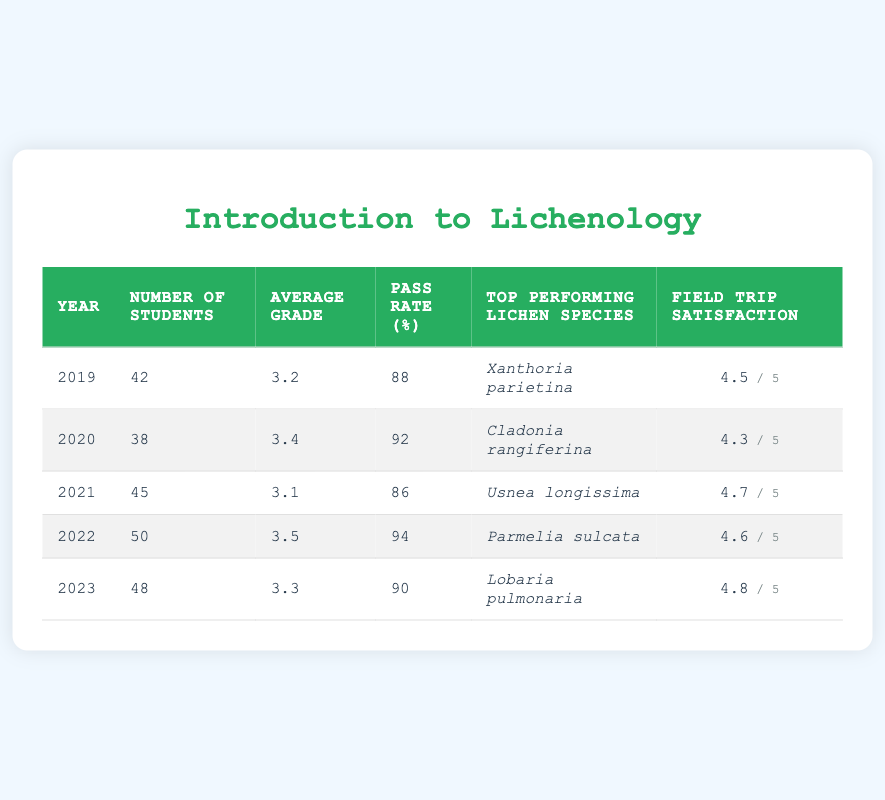What was the average grade of students in 2020? The average grade for the year 2020 is directly listed in the table under the "Average Grade" column. It shows a value of 3.4 for that year.
Answer: 3.4 How many students passed the course in 2021? The pass rate for 2021 is 86%. To find the number of students who passed, we calculate 86% of the 45 students, which is 0.86 * 45 = 38.7, rounding down gives us 38 students.
Answer: 38 What was the highest field trip satisfaction score recorded in the table? The field trip satisfaction scores are listed under the "Field Trip Satisfaction" column. Scanning through these values, the highest is 4.8 which corresponds to the year 2023.
Answer: 4.8 Did the number of students increase from 2019 to 2022? The number of students in 2019 was 42, and in 2022 it was 50. Since 50 is greater than 42, this confirms an increase from 2019 to 2022.
Answer: Yes What is the average pass rate over the five years? To find the average pass rate, we sum the pass rates from each year: (88 + 92 + 86 + 94 + 90) = 450. Then, we divide by the number of years, which is 5. So, the average pass rate is 450/5 = 90.
Answer: 90 Which year had the lowest average grade? By looking through the "Average Grade" column, we see that 3.1 in 2021 is the lowest value compared to other years.
Answer: 2021 What was the most commonly reported top-performing lichen species in the past five years? We look at the "Top Performing Lichen Species" column and see each species mentioned. The species listed are unique each year; hence, there is no most commonly reported species.
Answer: No common species How many students were there altogether over the five years? To find the total number of students, we sum the values from the "Number of Students" column: 42 + 38 + 45 + 50 + 48 = 223.
Answer: 223 Which year had the highest average grade and what was it? The average grades per year in the table show that 3.5 in 2022 is the highest grade. Therefore, 2022 had the highest average grade.
Answer: 2022, 3.5 